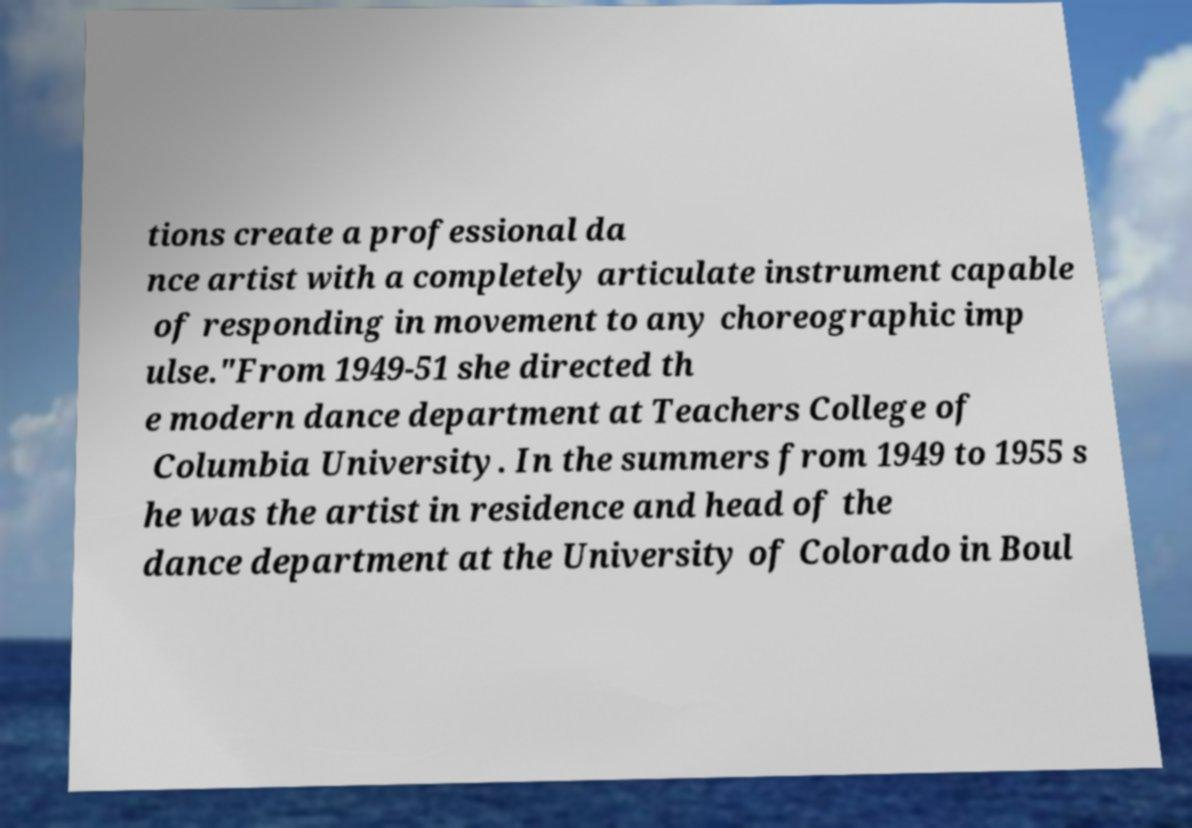Could you extract and type out the text from this image? tions create a professional da nce artist with a completely articulate instrument capable of responding in movement to any choreographic imp ulse."From 1949-51 she directed th e modern dance department at Teachers College of Columbia University. In the summers from 1949 to 1955 s he was the artist in residence and head of the dance department at the University of Colorado in Boul 